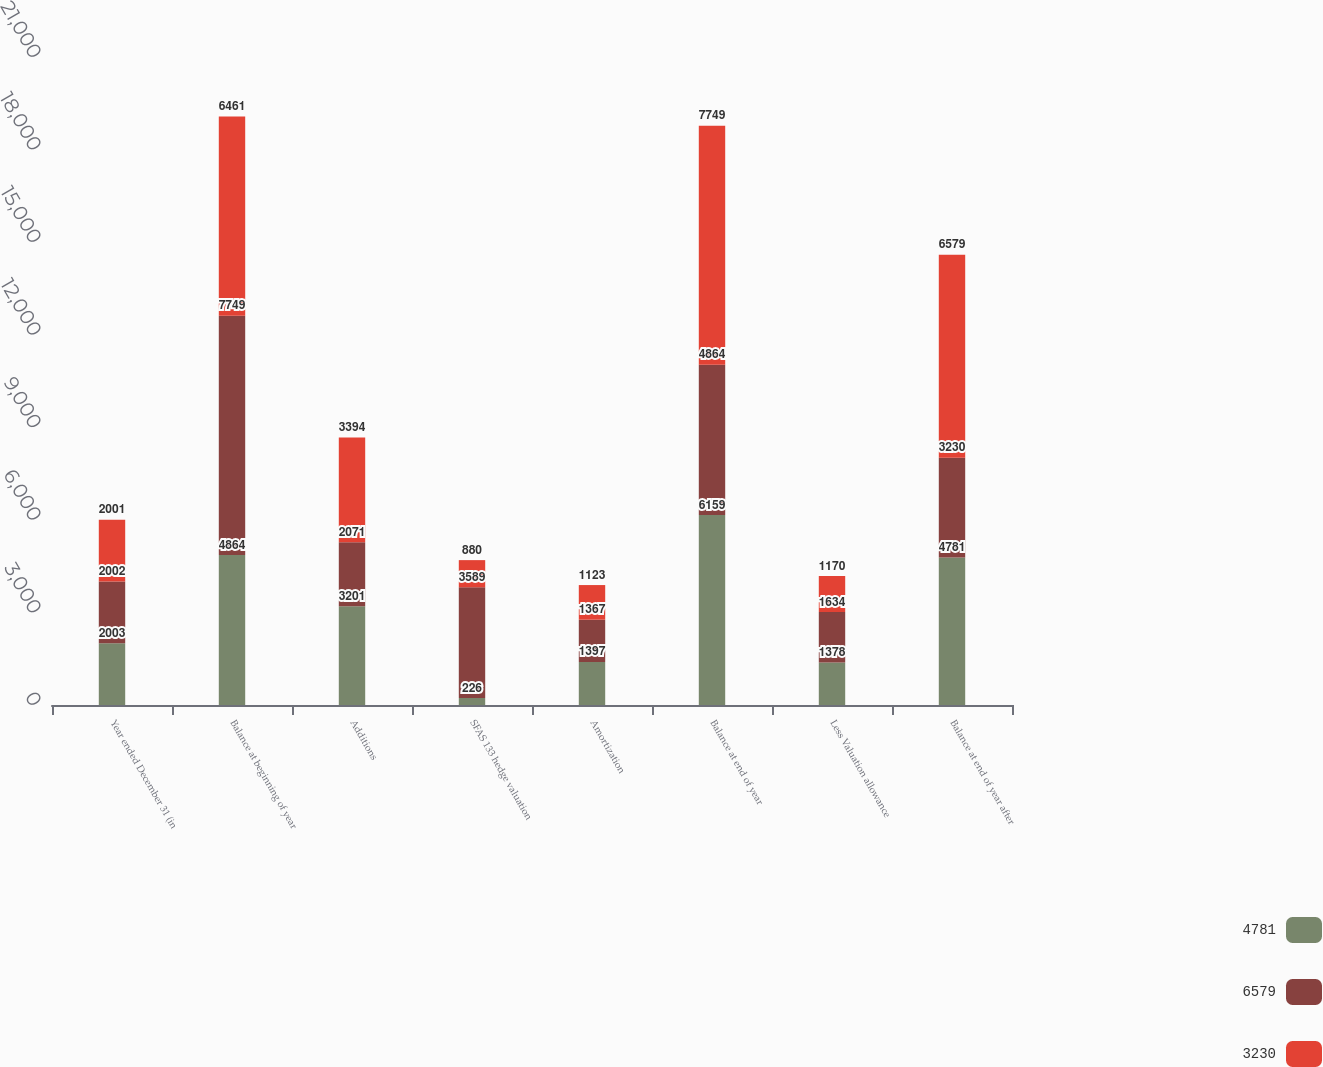Convert chart to OTSL. <chart><loc_0><loc_0><loc_500><loc_500><stacked_bar_chart><ecel><fcel>Year ended December 31 (in<fcel>Balance at beginning of year<fcel>Additions<fcel>SFAS 133 hedge valuation<fcel>Amortization<fcel>Balance at end of year<fcel>Less Valuation allowance<fcel>Balance at end of year after<nl><fcel>4781<fcel>2003<fcel>4864<fcel>3201<fcel>226<fcel>1397<fcel>6159<fcel>1378<fcel>4781<nl><fcel>6579<fcel>2002<fcel>7749<fcel>2071<fcel>3589<fcel>1367<fcel>4864<fcel>1634<fcel>3230<nl><fcel>3230<fcel>2001<fcel>6461<fcel>3394<fcel>880<fcel>1123<fcel>7749<fcel>1170<fcel>6579<nl></chart> 